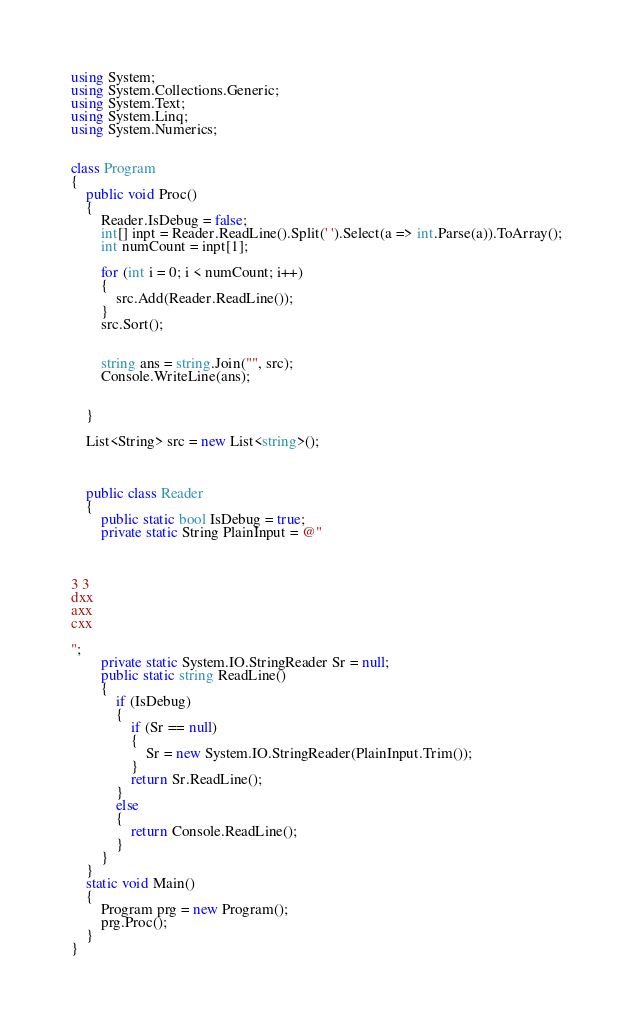<code> <loc_0><loc_0><loc_500><loc_500><_C#_>using System;
using System.Collections.Generic;
using System.Text;
using System.Linq;
using System.Numerics;


class Program
{
    public void Proc()
    {
        Reader.IsDebug = false;
        int[] inpt = Reader.ReadLine().Split(' ').Select(a => int.Parse(a)).ToArray();
        int numCount = inpt[1];

        for (int i = 0; i < numCount; i++)
        {
            src.Add(Reader.ReadLine());
        }
        src.Sort();


        string ans = string.Join("", src);
        Console.WriteLine(ans);


    }

    List<String> src = new List<string>();



    public class Reader
    {
        public static bool IsDebug = true;
        private static String PlainInput = @"



3 3
dxx
axx
cxx

";
        private static System.IO.StringReader Sr = null;
        public static string ReadLine()
        {
            if (IsDebug)
            {
                if (Sr == null)
                {
                    Sr = new System.IO.StringReader(PlainInput.Trim());
                }
                return Sr.ReadLine();
            }
            else
            {
                return Console.ReadLine();
            }
        }
    }
    static void Main()
    {
        Program prg = new Program();
        prg.Proc();
    }
}</code> 